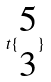Convert formula to latex. <formula><loc_0><loc_0><loc_500><loc_500>t \{ \begin{matrix} 5 \\ 3 \end{matrix} \}</formula> 